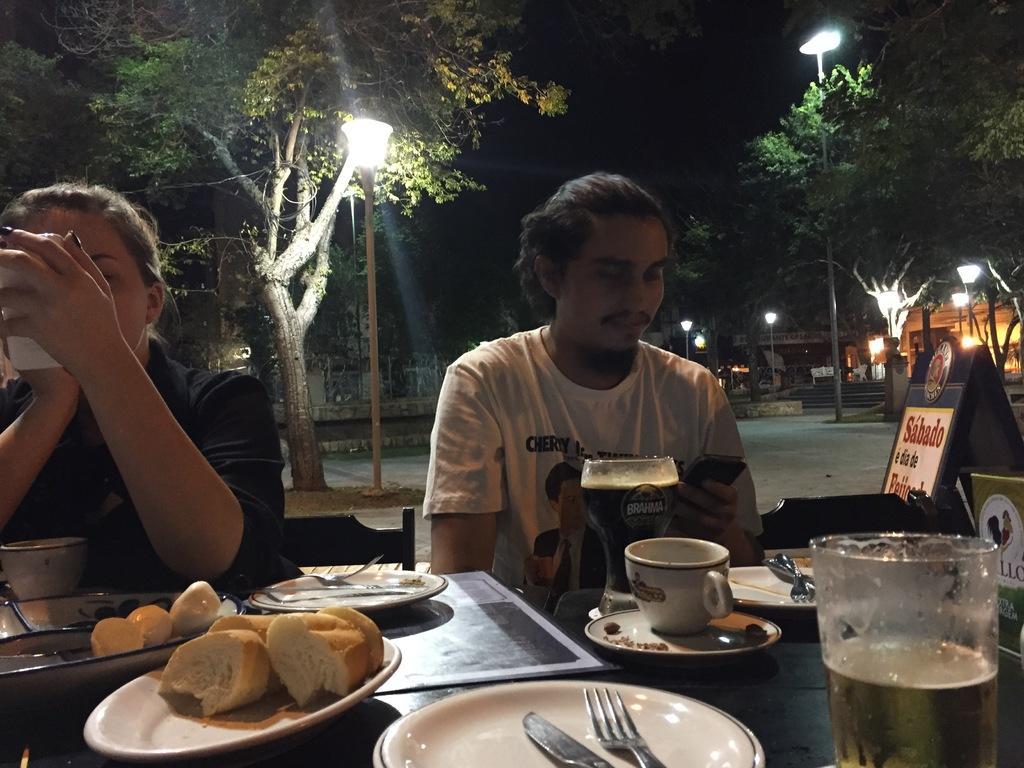In one or two sentences, can you explain what this image depicts? There is a person sitting on a chair and he is checking his mobile. There is a woman in the left side and she is also checking her mobile. This is a table where a plate, a glass, a cup, a spoon and a fork are kept on it. In the background we can see trees and street lights. 